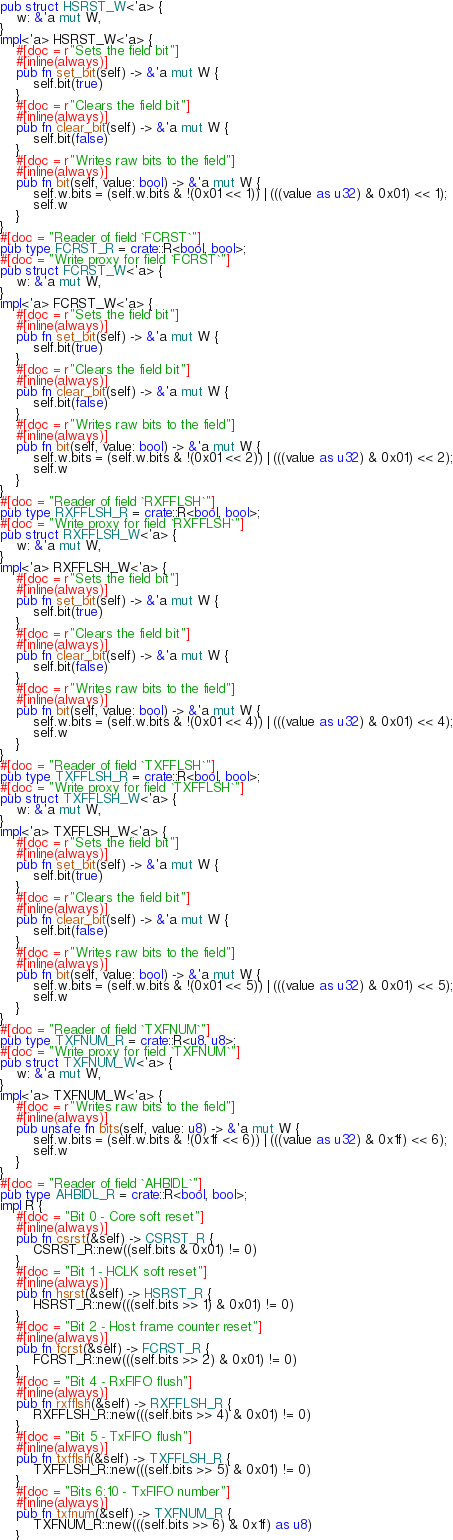Convert code to text. <code><loc_0><loc_0><loc_500><loc_500><_Rust_>pub struct HSRST_W<'a> {
    w: &'a mut W,
}
impl<'a> HSRST_W<'a> {
    #[doc = r"Sets the field bit"]
    #[inline(always)]
    pub fn set_bit(self) -> &'a mut W {
        self.bit(true)
    }
    #[doc = r"Clears the field bit"]
    #[inline(always)]
    pub fn clear_bit(self) -> &'a mut W {
        self.bit(false)
    }
    #[doc = r"Writes raw bits to the field"]
    #[inline(always)]
    pub fn bit(self, value: bool) -> &'a mut W {
        self.w.bits = (self.w.bits & !(0x01 << 1)) | (((value as u32) & 0x01) << 1);
        self.w
    }
}
#[doc = "Reader of field `FCRST`"]
pub type FCRST_R = crate::R<bool, bool>;
#[doc = "Write proxy for field `FCRST`"]
pub struct FCRST_W<'a> {
    w: &'a mut W,
}
impl<'a> FCRST_W<'a> {
    #[doc = r"Sets the field bit"]
    #[inline(always)]
    pub fn set_bit(self) -> &'a mut W {
        self.bit(true)
    }
    #[doc = r"Clears the field bit"]
    #[inline(always)]
    pub fn clear_bit(self) -> &'a mut W {
        self.bit(false)
    }
    #[doc = r"Writes raw bits to the field"]
    #[inline(always)]
    pub fn bit(self, value: bool) -> &'a mut W {
        self.w.bits = (self.w.bits & !(0x01 << 2)) | (((value as u32) & 0x01) << 2);
        self.w
    }
}
#[doc = "Reader of field `RXFFLSH`"]
pub type RXFFLSH_R = crate::R<bool, bool>;
#[doc = "Write proxy for field `RXFFLSH`"]
pub struct RXFFLSH_W<'a> {
    w: &'a mut W,
}
impl<'a> RXFFLSH_W<'a> {
    #[doc = r"Sets the field bit"]
    #[inline(always)]
    pub fn set_bit(self) -> &'a mut W {
        self.bit(true)
    }
    #[doc = r"Clears the field bit"]
    #[inline(always)]
    pub fn clear_bit(self) -> &'a mut W {
        self.bit(false)
    }
    #[doc = r"Writes raw bits to the field"]
    #[inline(always)]
    pub fn bit(self, value: bool) -> &'a mut W {
        self.w.bits = (self.w.bits & !(0x01 << 4)) | (((value as u32) & 0x01) << 4);
        self.w
    }
}
#[doc = "Reader of field `TXFFLSH`"]
pub type TXFFLSH_R = crate::R<bool, bool>;
#[doc = "Write proxy for field `TXFFLSH`"]
pub struct TXFFLSH_W<'a> {
    w: &'a mut W,
}
impl<'a> TXFFLSH_W<'a> {
    #[doc = r"Sets the field bit"]
    #[inline(always)]
    pub fn set_bit(self) -> &'a mut W {
        self.bit(true)
    }
    #[doc = r"Clears the field bit"]
    #[inline(always)]
    pub fn clear_bit(self) -> &'a mut W {
        self.bit(false)
    }
    #[doc = r"Writes raw bits to the field"]
    #[inline(always)]
    pub fn bit(self, value: bool) -> &'a mut W {
        self.w.bits = (self.w.bits & !(0x01 << 5)) | (((value as u32) & 0x01) << 5);
        self.w
    }
}
#[doc = "Reader of field `TXFNUM`"]
pub type TXFNUM_R = crate::R<u8, u8>;
#[doc = "Write proxy for field `TXFNUM`"]
pub struct TXFNUM_W<'a> {
    w: &'a mut W,
}
impl<'a> TXFNUM_W<'a> {
    #[doc = r"Writes raw bits to the field"]
    #[inline(always)]
    pub unsafe fn bits(self, value: u8) -> &'a mut W {
        self.w.bits = (self.w.bits & !(0x1f << 6)) | (((value as u32) & 0x1f) << 6);
        self.w
    }
}
#[doc = "Reader of field `AHBIDL`"]
pub type AHBIDL_R = crate::R<bool, bool>;
impl R {
    #[doc = "Bit 0 - Core soft reset"]
    #[inline(always)]
    pub fn csrst(&self) -> CSRST_R {
        CSRST_R::new((self.bits & 0x01) != 0)
    }
    #[doc = "Bit 1 - HCLK soft reset"]
    #[inline(always)]
    pub fn hsrst(&self) -> HSRST_R {
        HSRST_R::new(((self.bits >> 1) & 0x01) != 0)
    }
    #[doc = "Bit 2 - Host frame counter reset"]
    #[inline(always)]
    pub fn fcrst(&self) -> FCRST_R {
        FCRST_R::new(((self.bits >> 2) & 0x01) != 0)
    }
    #[doc = "Bit 4 - RxFIFO flush"]
    #[inline(always)]
    pub fn rxfflsh(&self) -> RXFFLSH_R {
        RXFFLSH_R::new(((self.bits >> 4) & 0x01) != 0)
    }
    #[doc = "Bit 5 - TxFIFO flush"]
    #[inline(always)]
    pub fn txfflsh(&self) -> TXFFLSH_R {
        TXFFLSH_R::new(((self.bits >> 5) & 0x01) != 0)
    }
    #[doc = "Bits 6:10 - TxFIFO number"]
    #[inline(always)]
    pub fn txfnum(&self) -> TXFNUM_R {
        TXFNUM_R::new(((self.bits >> 6) & 0x1f) as u8)
    }</code> 